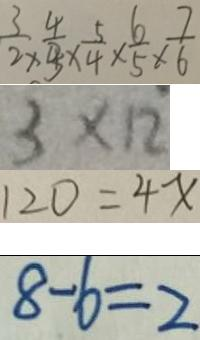Convert formula to latex. <formula><loc_0><loc_0><loc_500><loc_500>\frac { 3 } { 2 } \times \frac { 4 } { 3 } \times \frac { 5 } { 4 } \times \frac { 6 } { 5 } \times \frac { 7 } { 6 } 
 3 \times 1 2 
 1 2 0 = 4 x 
 8 - 6 = 2</formula> 